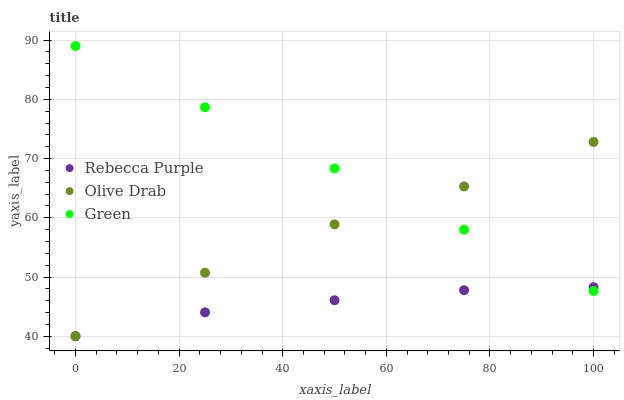Does Rebecca Purple have the minimum area under the curve?
Answer yes or no. Yes. Does Green have the maximum area under the curve?
Answer yes or no. Yes. Does Olive Drab have the minimum area under the curve?
Answer yes or no. No. Does Olive Drab have the maximum area under the curve?
Answer yes or no. No. Is Green the smoothest?
Answer yes or no. Yes. Is Olive Drab the roughest?
Answer yes or no. Yes. Is Rebecca Purple the smoothest?
Answer yes or no. No. Is Rebecca Purple the roughest?
Answer yes or no. No. Does Rebecca Purple have the lowest value?
Answer yes or no. Yes. Does Green have the highest value?
Answer yes or no. Yes. Does Olive Drab have the highest value?
Answer yes or no. No. Does Olive Drab intersect Green?
Answer yes or no. Yes. Is Olive Drab less than Green?
Answer yes or no. No. Is Olive Drab greater than Green?
Answer yes or no. No. 